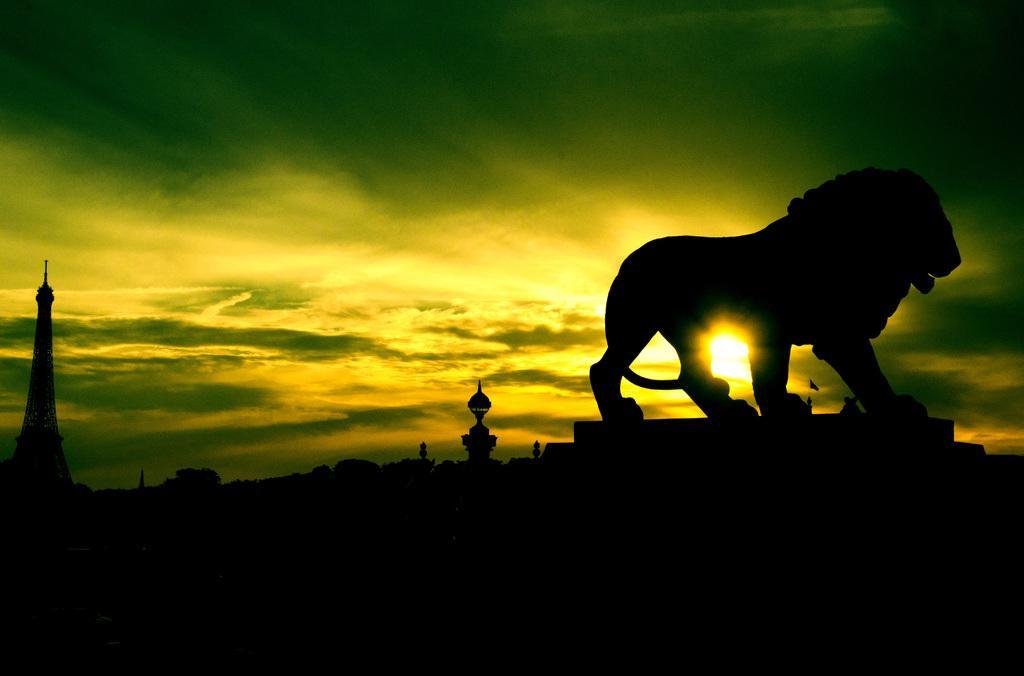Describe this image in one or two sentences. In this image we can see the tower. We can also see the depiction of a lion. In the background there is sky with the sun. 